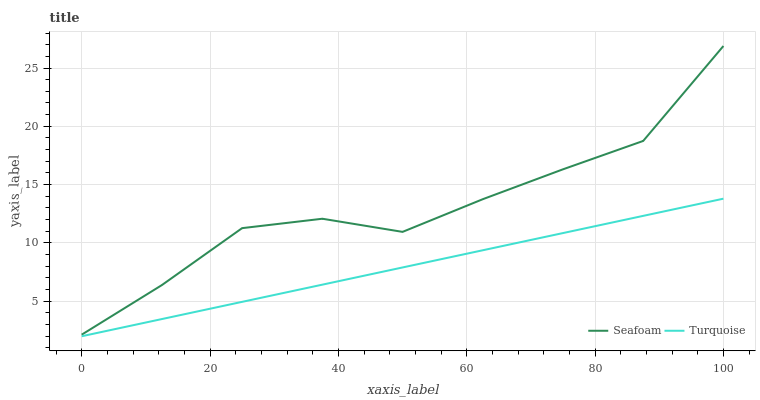Does Turquoise have the minimum area under the curve?
Answer yes or no. Yes. Does Seafoam have the maximum area under the curve?
Answer yes or no. Yes. Does Seafoam have the minimum area under the curve?
Answer yes or no. No. Is Turquoise the smoothest?
Answer yes or no. Yes. Is Seafoam the roughest?
Answer yes or no. Yes. Is Seafoam the smoothest?
Answer yes or no. No. Does Turquoise have the lowest value?
Answer yes or no. Yes. Does Seafoam have the lowest value?
Answer yes or no. No. Does Seafoam have the highest value?
Answer yes or no. Yes. Is Turquoise less than Seafoam?
Answer yes or no. Yes. Is Seafoam greater than Turquoise?
Answer yes or no. Yes. Does Turquoise intersect Seafoam?
Answer yes or no. No. 